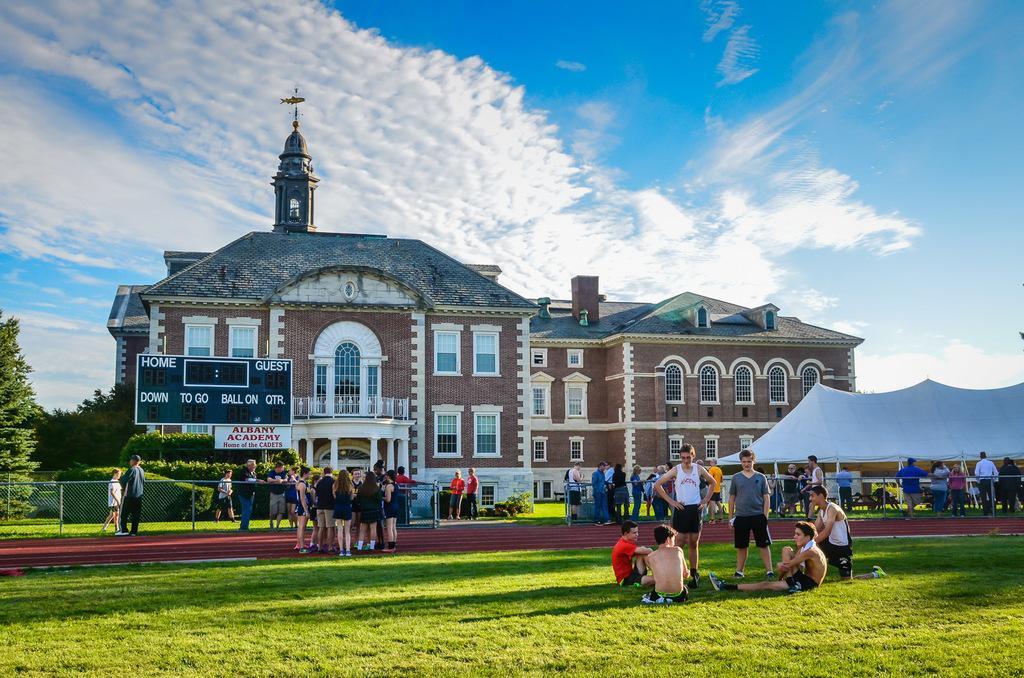In one or two sentences, can you explain what this image depicts? At the center of the image there is a building, in front of the building there is a board with some text and there are a few people sitting and standing, few are walking on the surface of the grass, there is a camp on the right side of the image. On the left side of the image there are trees and plants. In the background there is the sky. 